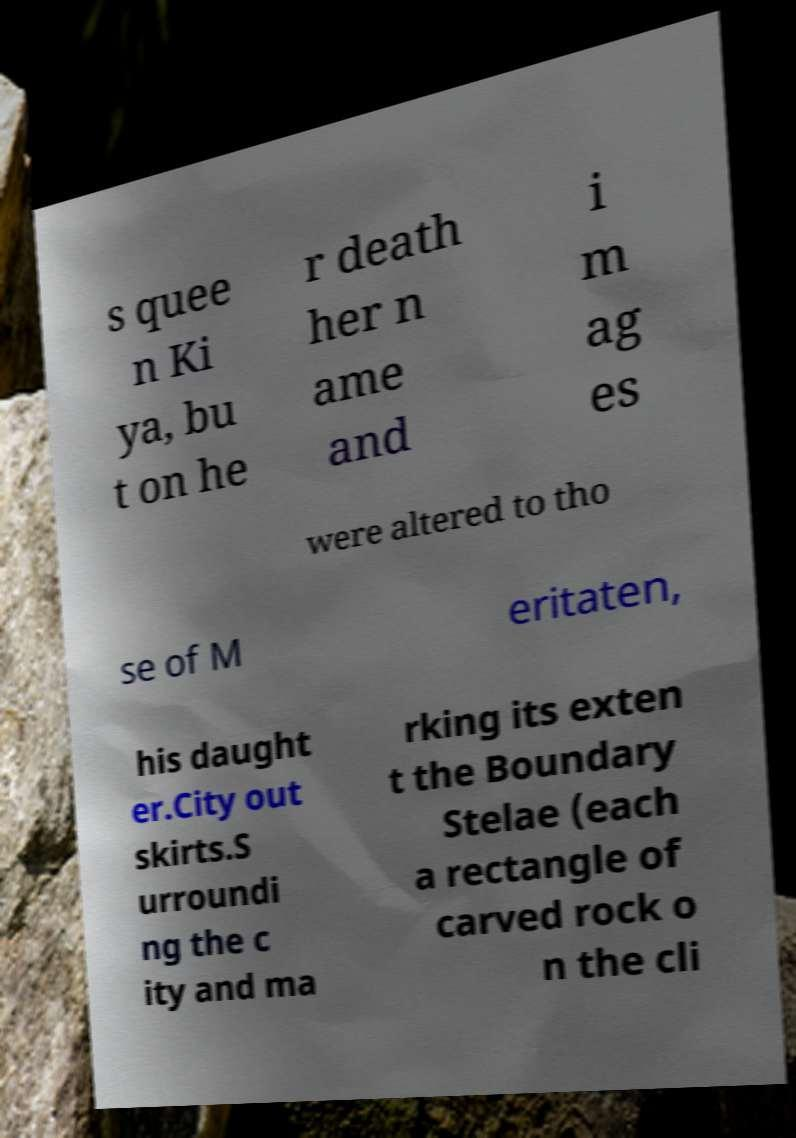Please read and relay the text visible in this image. What does it say? s quee n Ki ya, bu t on he r death her n ame and i m ag es were altered to tho se of M eritaten, his daught er.City out skirts.S urroundi ng the c ity and ma rking its exten t the Boundary Stelae (each a rectangle of carved rock o n the cli 